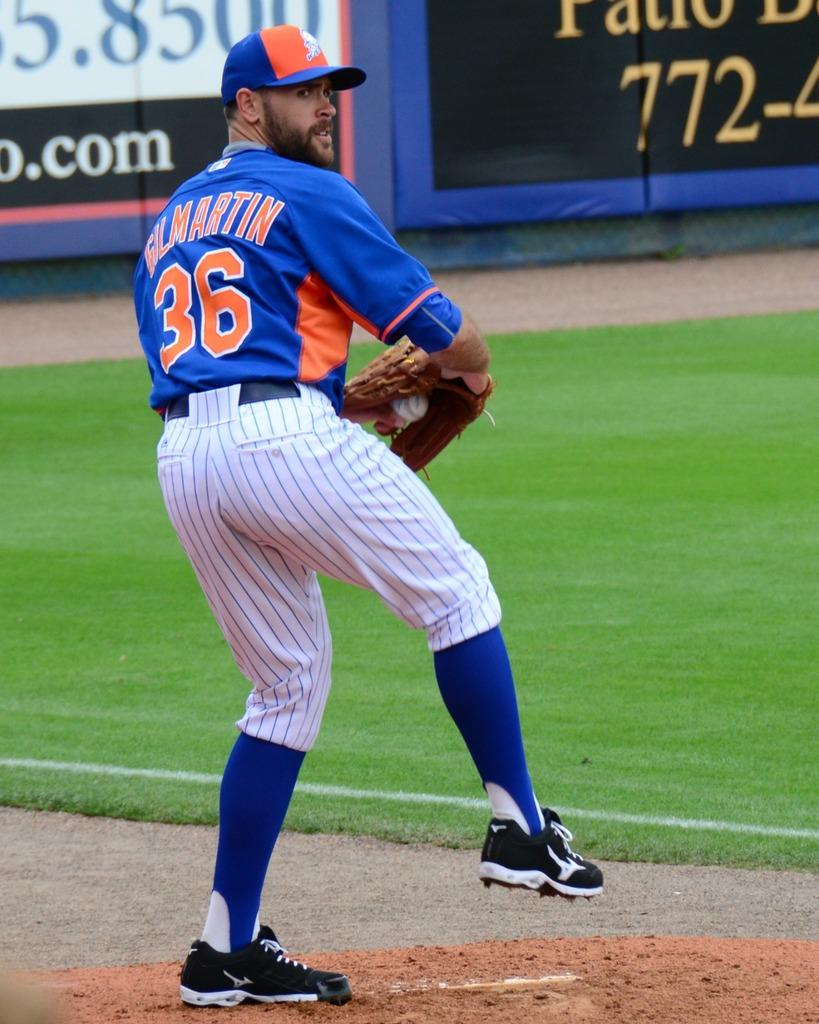Provide a one-sentence caption for the provided image. A man in a baseball uniform with the name Gil Martin and number 36 on the back of his jersey. 